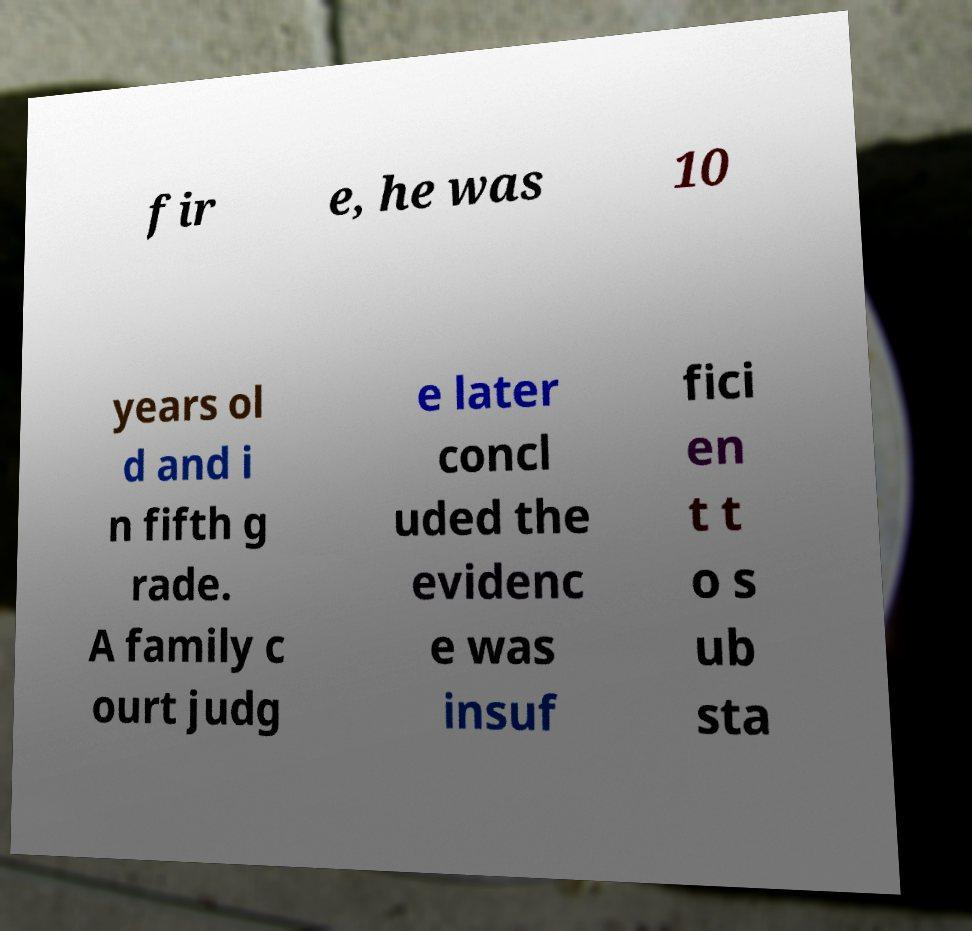What messages or text are displayed in this image? I need them in a readable, typed format. fir e, he was 10 years ol d and i n fifth g rade. A family c ourt judg e later concl uded the evidenc e was insuf fici en t t o s ub sta 